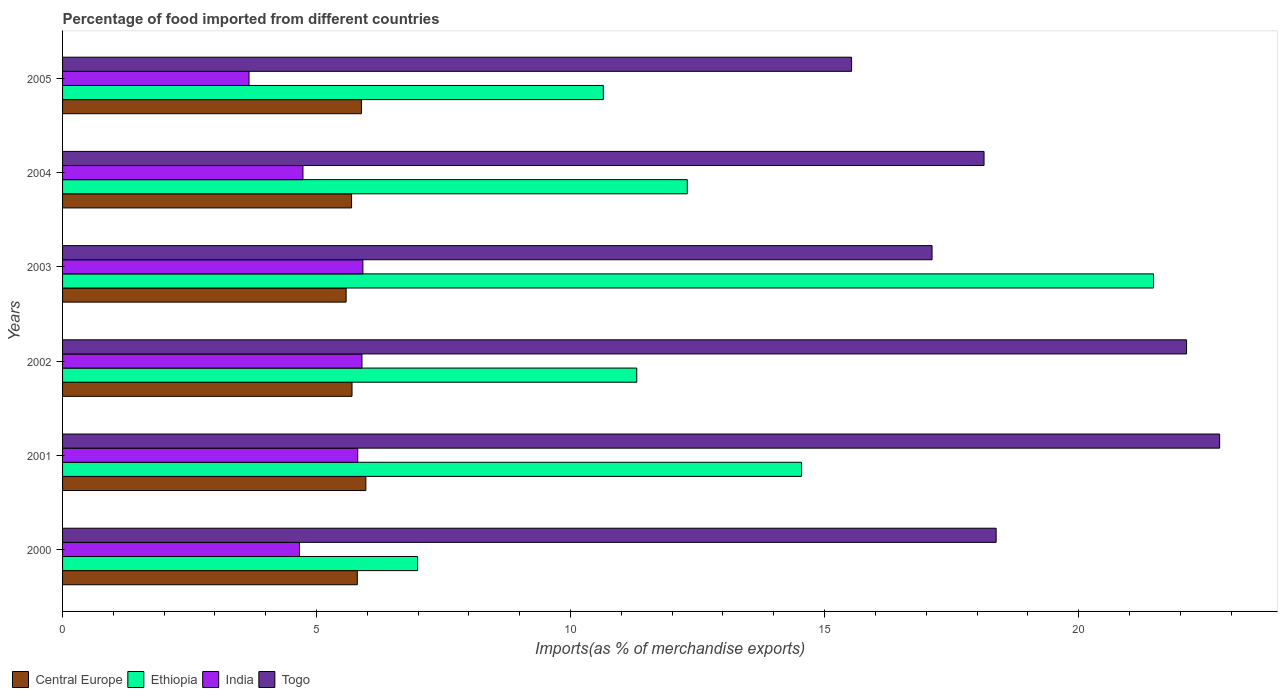How many groups of bars are there?
Offer a very short reply. 6. How many bars are there on the 4th tick from the top?
Make the answer very short. 4. How many bars are there on the 5th tick from the bottom?
Provide a succinct answer. 4. In how many cases, is the number of bars for a given year not equal to the number of legend labels?
Your answer should be very brief. 0. What is the percentage of imports to different countries in Togo in 2002?
Provide a short and direct response. 22.13. Across all years, what is the maximum percentage of imports to different countries in Togo?
Offer a very short reply. 22.78. Across all years, what is the minimum percentage of imports to different countries in Togo?
Make the answer very short. 15.53. What is the total percentage of imports to different countries in Central Europe in the graph?
Give a very brief answer. 34.62. What is the difference between the percentage of imports to different countries in Central Europe in 2002 and that in 2003?
Offer a very short reply. 0.12. What is the difference between the percentage of imports to different countries in Togo in 2000 and the percentage of imports to different countries in Central Europe in 2001?
Offer a very short reply. 12.41. What is the average percentage of imports to different countries in Ethiopia per year?
Make the answer very short. 12.88. In the year 2001, what is the difference between the percentage of imports to different countries in India and percentage of imports to different countries in Central Europe?
Give a very brief answer. -0.16. In how many years, is the percentage of imports to different countries in Central Europe greater than 8 %?
Offer a very short reply. 0. What is the ratio of the percentage of imports to different countries in Central Europe in 2000 to that in 2001?
Your response must be concise. 0.97. Is the percentage of imports to different countries in Ethiopia in 2000 less than that in 2003?
Keep it short and to the point. Yes. Is the difference between the percentage of imports to different countries in India in 2002 and 2003 greater than the difference between the percentage of imports to different countries in Central Europe in 2002 and 2003?
Make the answer very short. No. What is the difference between the highest and the second highest percentage of imports to different countries in Central Europe?
Make the answer very short. 0.09. What is the difference between the highest and the lowest percentage of imports to different countries in Togo?
Provide a short and direct response. 7.24. Is the sum of the percentage of imports to different countries in Central Europe in 2002 and 2003 greater than the maximum percentage of imports to different countries in Togo across all years?
Ensure brevity in your answer.  No. What does the 3rd bar from the top in 2001 represents?
Provide a short and direct response. Ethiopia. What does the 2nd bar from the bottom in 2003 represents?
Your answer should be compact. Ethiopia. Is it the case that in every year, the sum of the percentage of imports to different countries in India and percentage of imports to different countries in Togo is greater than the percentage of imports to different countries in Ethiopia?
Offer a very short reply. Yes. How many bars are there?
Provide a short and direct response. 24. Are all the bars in the graph horizontal?
Your response must be concise. Yes. How many years are there in the graph?
Provide a short and direct response. 6. What is the difference between two consecutive major ticks on the X-axis?
Your answer should be compact. 5. Does the graph contain any zero values?
Make the answer very short. No. Where does the legend appear in the graph?
Keep it short and to the point. Bottom left. How many legend labels are there?
Provide a succinct answer. 4. How are the legend labels stacked?
Make the answer very short. Horizontal. What is the title of the graph?
Make the answer very short. Percentage of food imported from different countries. What is the label or title of the X-axis?
Provide a succinct answer. Imports(as % of merchandise exports). What is the Imports(as % of merchandise exports) in Central Europe in 2000?
Give a very brief answer. 5.8. What is the Imports(as % of merchandise exports) in Ethiopia in 2000?
Provide a succinct answer. 6.99. What is the Imports(as % of merchandise exports) in India in 2000?
Your response must be concise. 4.66. What is the Imports(as % of merchandise exports) in Togo in 2000?
Your response must be concise. 18.38. What is the Imports(as % of merchandise exports) of Central Europe in 2001?
Ensure brevity in your answer.  5.97. What is the Imports(as % of merchandise exports) of Ethiopia in 2001?
Offer a very short reply. 14.55. What is the Imports(as % of merchandise exports) in India in 2001?
Provide a succinct answer. 5.81. What is the Imports(as % of merchandise exports) in Togo in 2001?
Offer a very short reply. 22.78. What is the Imports(as % of merchandise exports) in Central Europe in 2002?
Your response must be concise. 5.7. What is the Imports(as % of merchandise exports) of Ethiopia in 2002?
Provide a short and direct response. 11.3. What is the Imports(as % of merchandise exports) in India in 2002?
Keep it short and to the point. 5.89. What is the Imports(as % of merchandise exports) of Togo in 2002?
Provide a short and direct response. 22.13. What is the Imports(as % of merchandise exports) of Central Europe in 2003?
Give a very brief answer. 5.58. What is the Imports(as % of merchandise exports) in Ethiopia in 2003?
Your response must be concise. 21.47. What is the Imports(as % of merchandise exports) in India in 2003?
Ensure brevity in your answer.  5.91. What is the Imports(as % of merchandise exports) in Togo in 2003?
Offer a terse response. 17.12. What is the Imports(as % of merchandise exports) of Central Europe in 2004?
Your answer should be compact. 5.69. What is the Imports(as % of merchandise exports) in Ethiopia in 2004?
Your answer should be very brief. 12.3. What is the Imports(as % of merchandise exports) in India in 2004?
Offer a very short reply. 4.73. What is the Imports(as % of merchandise exports) in Togo in 2004?
Make the answer very short. 18.14. What is the Imports(as % of merchandise exports) of Central Europe in 2005?
Give a very brief answer. 5.88. What is the Imports(as % of merchandise exports) in Ethiopia in 2005?
Offer a very short reply. 10.64. What is the Imports(as % of merchandise exports) of India in 2005?
Your response must be concise. 3.67. What is the Imports(as % of merchandise exports) in Togo in 2005?
Your answer should be very brief. 15.53. Across all years, what is the maximum Imports(as % of merchandise exports) in Central Europe?
Your response must be concise. 5.97. Across all years, what is the maximum Imports(as % of merchandise exports) in Ethiopia?
Provide a short and direct response. 21.47. Across all years, what is the maximum Imports(as % of merchandise exports) of India?
Provide a short and direct response. 5.91. Across all years, what is the maximum Imports(as % of merchandise exports) of Togo?
Provide a short and direct response. 22.78. Across all years, what is the minimum Imports(as % of merchandise exports) of Central Europe?
Give a very brief answer. 5.58. Across all years, what is the minimum Imports(as % of merchandise exports) of Ethiopia?
Your answer should be very brief. 6.99. Across all years, what is the minimum Imports(as % of merchandise exports) of India?
Offer a very short reply. 3.67. Across all years, what is the minimum Imports(as % of merchandise exports) in Togo?
Give a very brief answer. 15.53. What is the total Imports(as % of merchandise exports) of Central Europe in the graph?
Give a very brief answer. 34.62. What is the total Imports(as % of merchandise exports) of Ethiopia in the graph?
Your response must be concise. 77.26. What is the total Imports(as % of merchandise exports) of India in the graph?
Your answer should be compact. 30.68. What is the total Imports(as % of merchandise exports) in Togo in the graph?
Make the answer very short. 114.06. What is the difference between the Imports(as % of merchandise exports) in Central Europe in 2000 and that in 2001?
Provide a succinct answer. -0.17. What is the difference between the Imports(as % of merchandise exports) in Ethiopia in 2000 and that in 2001?
Offer a very short reply. -7.56. What is the difference between the Imports(as % of merchandise exports) in India in 2000 and that in 2001?
Your answer should be compact. -1.15. What is the difference between the Imports(as % of merchandise exports) in Togo in 2000 and that in 2001?
Make the answer very short. -4.4. What is the difference between the Imports(as % of merchandise exports) of Central Europe in 2000 and that in 2002?
Your answer should be compact. 0.1. What is the difference between the Imports(as % of merchandise exports) in Ethiopia in 2000 and that in 2002?
Provide a short and direct response. -4.31. What is the difference between the Imports(as % of merchandise exports) in India in 2000 and that in 2002?
Your answer should be very brief. -1.23. What is the difference between the Imports(as % of merchandise exports) in Togo in 2000 and that in 2002?
Keep it short and to the point. -3.75. What is the difference between the Imports(as % of merchandise exports) in Central Europe in 2000 and that in 2003?
Provide a succinct answer. 0.22. What is the difference between the Imports(as % of merchandise exports) of Ethiopia in 2000 and that in 2003?
Provide a succinct answer. -14.49. What is the difference between the Imports(as % of merchandise exports) in India in 2000 and that in 2003?
Keep it short and to the point. -1.25. What is the difference between the Imports(as % of merchandise exports) of Togo in 2000 and that in 2003?
Keep it short and to the point. 1.26. What is the difference between the Imports(as % of merchandise exports) in Central Europe in 2000 and that in 2004?
Offer a terse response. 0.11. What is the difference between the Imports(as % of merchandise exports) in Ethiopia in 2000 and that in 2004?
Your answer should be compact. -5.31. What is the difference between the Imports(as % of merchandise exports) in India in 2000 and that in 2004?
Make the answer very short. -0.07. What is the difference between the Imports(as % of merchandise exports) in Togo in 2000 and that in 2004?
Your response must be concise. 0.24. What is the difference between the Imports(as % of merchandise exports) of Central Europe in 2000 and that in 2005?
Give a very brief answer. -0.08. What is the difference between the Imports(as % of merchandise exports) in Ethiopia in 2000 and that in 2005?
Ensure brevity in your answer.  -3.66. What is the difference between the Imports(as % of merchandise exports) of India in 2000 and that in 2005?
Give a very brief answer. 0.99. What is the difference between the Imports(as % of merchandise exports) in Togo in 2000 and that in 2005?
Provide a succinct answer. 2.85. What is the difference between the Imports(as % of merchandise exports) of Central Europe in 2001 and that in 2002?
Ensure brevity in your answer.  0.27. What is the difference between the Imports(as % of merchandise exports) of Ethiopia in 2001 and that in 2002?
Your response must be concise. 3.24. What is the difference between the Imports(as % of merchandise exports) of India in 2001 and that in 2002?
Offer a terse response. -0.08. What is the difference between the Imports(as % of merchandise exports) in Togo in 2001 and that in 2002?
Provide a succinct answer. 0.65. What is the difference between the Imports(as % of merchandise exports) in Central Europe in 2001 and that in 2003?
Offer a very short reply. 0.39. What is the difference between the Imports(as % of merchandise exports) of Ethiopia in 2001 and that in 2003?
Offer a very short reply. -6.93. What is the difference between the Imports(as % of merchandise exports) of India in 2001 and that in 2003?
Your response must be concise. -0.1. What is the difference between the Imports(as % of merchandise exports) of Togo in 2001 and that in 2003?
Provide a succinct answer. 5.66. What is the difference between the Imports(as % of merchandise exports) in Central Europe in 2001 and that in 2004?
Provide a short and direct response. 0.28. What is the difference between the Imports(as % of merchandise exports) in Ethiopia in 2001 and that in 2004?
Ensure brevity in your answer.  2.25. What is the difference between the Imports(as % of merchandise exports) of India in 2001 and that in 2004?
Offer a terse response. 1.08. What is the difference between the Imports(as % of merchandise exports) of Togo in 2001 and that in 2004?
Your answer should be compact. 4.64. What is the difference between the Imports(as % of merchandise exports) of Central Europe in 2001 and that in 2005?
Provide a short and direct response. 0.09. What is the difference between the Imports(as % of merchandise exports) in Ethiopia in 2001 and that in 2005?
Your response must be concise. 3.9. What is the difference between the Imports(as % of merchandise exports) in India in 2001 and that in 2005?
Offer a terse response. 2.14. What is the difference between the Imports(as % of merchandise exports) in Togo in 2001 and that in 2005?
Give a very brief answer. 7.24. What is the difference between the Imports(as % of merchandise exports) in Central Europe in 2002 and that in 2003?
Your response must be concise. 0.12. What is the difference between the Imports(as % of merchandise exports) of Ethiopia in 2002 and that in 2003?
Keep it short and to the point. -10.17. What is the difference between the Imports(as % of merchandise exports) in India in 2002 and that in 2003?
Offer a terse response. -0.02. What is the difference between the Imports(as % of merchandise exports) of Togo in 2002 and that in 2003?
Offer a very short reply. 5.01. What is the difference between the Imports(as % of merchandise exports) in Central Europe in 2002 and that in 2004?
Give a very brief answer. 0.01. What is the difference between the Imports(as % of merchandise exports) of Ethiopia in 2002 and that in 2004?
Offer a very short reply. -0.99. What is the difference between the Imports(as % of merchandise exports) of India in 2002 and that in 2004?
Ensure brevity in your answer.  1.16. What is the difference between the Imports(as % of merchandise exports) in Togo in 2002 and that in 2004?
Your response must be concise. 3.99. What is the difference between the Imports(as % of merchandise exports) in Central Europe in 2002 and that in 2005?
Offer a terse response. -0.19. What is the difference between the Imports(as % of merchandise exports) in Ethiopia in 2002 and that in 2005?
Your response must be concise. 0.66. What is the difference between the Imports(as % of merchandise exports) in India in 2002 and that in 2005?
Offer a very short reply. 2.22. What is the difference between the Imports(as % of merchandise exports) in Togo in 2002 and that in 2005?
Ensure brevity in your answer.  6.59. What is the difference between the Imports(as % of merchandise exports) in Central Europe in 2003 and that in 2004?
Ensure brevity in your answer.  -0.11. What is the difference between the Imports(as % of merchandise exports) of Ethiopia in 2003 and that in 2004?
Provide a short and direct response. 9.18. What is the difference between the Imports(as % of merchandise exports) in India in 2003 and that in 2004?
Your response must be concise. 1.18. What is the difference between the Imports(as % of merchandise exports) of Togo in 2003 and that in 2004?
Your answer should be very brief. -1.02. What is the difference between the Imports(as % of merchandise exports) in Central Europe in 2003 and that in 2005?
Your answer should be very brief. -0.3. What is the difference between the Imports(as % of merchandise exports) of Ethiopia in 2003 and that in 2005?
Make the answer very short. 10.83. What is the difference between the Imports(as % of merchandise exports) of India in 2003 and that in 2005?
Keep it short and to the point. 2.24. What is the difference between the Imports(as % of merchandise exports) of Togo in 2003 and that in 2005?
Make the answer very short. 1.58. What is the difference between the Imports(as % of merchandise exports) in Central Europe in 2004 and that in 2005?
Provide a succinct answer. -0.19. What is the difference between the Imports(as % of merchandise exports) in Ethiopia in 2004 and that in 2005?
Ensure brevity in your answer.  1.65. What is the difference between the Imports(as % of merchandise exports) in India in 2004 and that in 2005?
Offer a very short reply. 1.06. What is the difference between the Imports(as % of merchandise exports) of Togo in 2004 and that in 2005?
Give a very brief answer. 2.61. What is the difference between the Imports(as % of merchandise exports) in Central Europe in 2000 and the Imports(as % of merchandise exports) in Ethiopia in 2001?
Keep it short and to the point. -8.74. What is the difference between the Imports(as % of merchandise exports) of Central Europe in 2000 and the Imports(as % of merchandise exports) of India in 2001?
Keep it short and to the point. -0.01. What is the difference between the Imports(as % of merchandise exports) in Central Europe in 2000 and the Imports(as % of merchandise exports) in Togo in 2001?
Keep it short and to the point. -16.97. What is the difference between the Imports(as % of merchandise exports) in Ethiopia in 2000 and the Imports(as % of merchandise exports) in India in 2001?
Offer a terse response. 1.18. What is the difference between the Imports(as % of merchandise exports) of Ethiopia in 2000 and the Imports(as % of merchandise exports) of Togo in 2001?
Ensure brevity in your answer.  -15.79. What is the difference between the Imports(as % of merchandise exports) in India in 2000 and the Imports(as % of merchandise exports) in Togo in 2001?
Your answer should be very brief. -18.11. What is the difference between the Imports(as % of merchandise exports) of Central Europe in 2000 and the Imports(as % of merchandise exports) of Ethiopia in 2002?
Give a very brief answer. -5.5. What is the difference between the Imports(as % of merchandise exports) in Central Europe in 2000 and the Imports(as % of merchandise exports) in India in 2002?
Offer a very short reply. -0.09. What is the difference between the Imports(as % of merchandise exports) of Central Europe in 2000 and the Imports(as % of merchandise exports) of Togo in 2002?
Offer a very short reply. -16.32. What is the difference between the Imports(as % of merchandise exports) of Ethiopia in 2000 and the Imports(as % of merchandise exports) of India in 2002?
Your answer should be compact. 1.1. What is the difference between the Imports(as % of merchandise exports) of Ethiopia in 2000 and the Imports(as % of merchandise exports) of Togo in 2002?
Give a very brief answer. -15.14. What is the difference between the Imports(as % of merchandise exports) in India in 2000 and the Imports(as % of merchandise exports) in Togo in 2002?
Your answer should be very brief. -17.46. What is the difference between the Imports(as % of merchandise exports) in Central Europe in 2000 and the Imports(as % of merchandise exports) in Ethiopia in 2003?
Keep it short and to the point. -15.67. What is the difference between the Imports(as % of merchandise exports) in Central Europe in 2000 and the Imports(as % of merchandise exports) in India in 2003?
Your answer should be very brief. -0.11. What is the difference between the Imports(as % of merchandise exports) of Central Europe in 2000 and the Imports(as % of merchandise exports) of Togo in 2003?
Provide a short and direct response. -11.31. What is the difference between the Imports(as % of merchandise exports) in Ethiopia in 2000 and the Imports(as % of merchandise exports) in India in 2003?
Your response must be concise. 1.08. What is the difference between the Imports(as % of merchandise exports) in Ethiopia in 2000 and the Imports(as % of merchandise exports) in Togo in 2003?
Make the answer very short. -10.13. What is the difference between the Imports(as % of merchandise exports) in India in 2000 and the Imports(as % of merchandise exports) in Togo in 2003?
Your response must be concise. -12.45. What is the difference between the Imports(as % of merchandise exports) in Central Europe in 2000 and the Imports(as % of merchandise exports) in Ethiopia in 2004?
Give a very brief answer. -6.5. What is the difference between the Imports(as % of merchandise exports) in Central Europe in 2000 and the Imports(as % of merchandise exports) in India in 2004?
Your answer should be compact. 1.07. What is the difference between the Imports(as % of merchandise exports) of Central Europe in 2000 and the Imports(as % of merchandise exports) of Togo in 2004?
Give a very brief answer. -12.34. What is the difference between the Imports(as % of merchandise exports) in Ethiopia in 2000 and the Imports(as % of merchandise exports) in India in 2004?
Your response must be concise. 2.26. What is the difference between the Imports(as % of merchandise exports) of Ethiopia in 2000 and the Imports(as % of merchandise exports) of Togo in 2004?
Make the answer very short. -11.15. What is the difference between the Imports(as % of merchandise exports) in India in 2000 and the Imports(as % of merchandise exports) in Togo in 2004?
Provide a short and direct response. -13.48. What is the difference between the Imports(as % of merchandise exports) of Central Europe in 2000 and the Imports(as % of merchandise exports) of Ethiopia in 2005?
Your answer should be very brief. -4.84. What is the difference between the Imports(as % of merchandise exports) in Central Europe in 2000 and the Imports(as % of merchandise exports) in India in 2005?
Offer a very short reply. 2.13. What is the difference between the Imports(as % of merchandise exports) in Central Europe in 2000 and the Imports(as % of merchandise exports) in Togo in 2005?
Keep it short and to the point. -9.73. What is the difference between the Imports(as % of merchandise exports) of Ethiopia in 2000 and the Imports(as % of merchandise exports) of India in 2005?
Ensure brevity in your answer.  3.32. What is the difference between the Imports(as % of merchandise exports) in Ethiopia in 2000 and the Imports(as % of merchandise exports) in Togo in 2005?
Provide a succinct answer. -8.54. What is the difference between the Imports(as % of merchandise exports) of India in 2000 and the Imports(as % of merchandise exports) of Togo in 2005?
Make the answer very short. -10.87. What is the difference between the Imports(as % of merchandise exports) of Central Europe in 2001 and the Imports(as % of merchandise exports) of Ethiopia in 2002?
Offer a terse response. -5.33. What is the difference between the Imports(as % of merchandise exports) of Central Europe in 2001 and the Imports(as % of merchandise exports) of India in 2002?
Make the answer very short. 0.08. What is the difference between the Imports(as % of merchandise exports) of Central Europe in 2001 and the Imports(as % of merchandise exports) of Togo in 2002?
Ensure brevity in your answer.  -16.15. What is the difference between the Imports(as % of merchandise exports) in Ethiopia in 2001 and the Imports(as % of merchandise exports) in India in 2002?
Give a very brief answer. 8.65. What is the difference between the Imports(as % of merchandise exports) in Ethiopia in 2001 and the Imports(as % of merchandise exports) in Togo in 2002?
Offer a terse response. -7.58. What is the difference between the Imports(as % of merchandise exports) of India in 2001 and the Imports(as % of merchandise exports) of Togo in 2002?
Provide a succinct answer. -16.32. What is the difference between the Imports(as % of merchandise exports) of Central Europe in 2001 and the Imports(as % of merchandise exports) of Ethiopia in 2003?
Your response must be concise. -15.5. What is the difference between the Imports(as % of merchandise exports) in Central Europe in 2001 and the Imports(as % of merchandise exports) in India in 2003?
Ensure brevity in your answer.  0.06. What is the difference between the Imports(as % of merchandise exports) of Central Europe in 2001 and the Imports(as % of merchandise exports) of Togo in 2003?
Provide a short and direct response. -11.15. What is the difference between the Imports(as % of merchandise exports) in Ethiopia in 2001 and the Imports(as % of merchandise exports) in India in 2003?
Your answer should be very brief. 8.64. What is the difference between the Imports(as % of merchandise exports) of Ethiopia in 2001 and the Imports(as % of merchandise exports) of Togo in 2003?
Offer a terse response. -2.57. What is the difference between the Imports(as % of merchandise exports) of India in 2001 and the Imports(as % of merchandise exports) of Togo in 2003?
Ensure brevity in your answer.  -11.31. What is the difference between the Imports(as % of merchandise exports) in Central Europe in 2001 and the Imports(as % of merchandise exports) in Ethiopia in 2004?
Your response must be concise. -6.33. What is the difference between the Imports(as % of merchandise exports) in Central Europe in 2001 and the Imports(as % of merchandise exports) in India in 2004?
Your answer should be very brief. 1.24. What is the difference between the Imports(as % of merchandise exports) in Central Europe in 2001 and the Imports(as % of merchandise exports) in Togo in 2004?
Your answer should be compact. -12.17. What is the difference between the Imports(as % of merchandise exports) of Ethiopia in 2001 and the Imports(as % of merchandise exports) of India in 2004?
Your answer should be very brief. 9.81. What is the difference between the Imports(as % of merchandise exports) of Ethiopia in 2001 and the Imports(as % of merchandise exports) of Togo in 2004?
Provide a short and direct response. -3.59. What is the difference between the Imports(as % of merchandise exports) of India in 2001 and the Imports(as % of merchandise exports) of Togo in 2004?
Make the answer very short. -12.33. What is the difference between the Imports(as % of merchandise exports) in Central Europe in 2001 and the Imports(as % of merchandise exports) in Ethiopia in 2005?
Ensure brevity in your answer.  -4.67. What is the difference between the Imports(as % of merchandise exports) in Central Europe in 2001 and the Imports(as % of merchandise exports) in India in 2005?
Offer a terse response. 2.3. What is the difference between the Imports(as % of merchandise exports) of Central Europe in 2001 and the Imports(as % of merchandise exports) of Togo in 2005?
Your answer should be compact. -9.56. What is the difference between the Imports(as % of merchandise exports) of Ethiopia in 2001 and the Imports(as % of merchandise exports) of India in 2005?
Make the answer very short. 10.88. What is the difference between the Imports(as % of merchandise exports) in Ethiopia in 2001 and the Imports(as % of merchandise exports) in Togo in 2005?
Provide a succinct answer. -0.98. What is the difference between the Imports(as % of merchandise exports) of India in 2001 and the Imports(as % of merchandise exports) of Togo in 2005?
Your response must be concise. -9.72. What is the difference between the Imports(as % of merchandise exports) of Central Europe in 2002 and the Imports(as % of merchandise exports) of Ethiopia in 2003?
Keep it short and to the point. -15.78. What is the difference between the Imports(as % of merchandise exports) of Central Europe in 2002 and the Imports(as % of merchandise exports) of India in 2003?
Your response must be concise. -0.21. What is the difference between the Imports(as % of merchandise exports) in Central Europe in 2002 and the Imports(as % of merchandise exports) in Togo in 2003?
Give a very brief answer. -11.42. What is the difference between the Imports(as % of merchandise exports) in Ethiopia in 2002 and the Imports(as % of merchandise exports) in India in 2003?
Offer a terse response. 5.39. What is the difference between the Imports(as % of merchandise exports) in Ethiopia in 2002 and the Imports(as % of merchandise exports) in Togo in 2003?
Your response must be concise. -5.81. What is the difference between the Imports(as % of merchandise exports) of India in 2002 and the Imports(as % of merchandise exports) of Togo in 2003?
Offer a terse response. -11.22. What is the difference between the Imports(as % of merchandise exports) in Central Europe in 2002 and the Imports(as % of merchandise exports) in Ethiopia in 2004?
Make the answer very short. -6.6. What is the difference between the Imports(as % of merchandise exports) of Central Europe in 2002 and the Imports(as % of merchandise exports) of India in 2004?
Your answer should be very brief. 0.97. What is the difference between the Imports(as % of merchandise exports) of Central Europe in 2002 and the Imports(as % of merchandise exports) of Togo in 2004?
Your answer should be compact. -12.44. What is the difference between the Imports(as % of merchandise exports) in Ethiopia in 2002 and the Imports(as % of merchandise exports) in India in 2004?
Offer a terse response. 6.57. What is the difference between the Imports(as % of merchandise exports) in Ethiopia in 2002 and the Imports(as % of merchandise exports) in Togo in 2004?
Offer a very short reply. -6.84. What is the difference between the Imports(as % of merchandise exports) in India in 2002 and the Imports(as % of merchandise exports) in Togo in 2004?
Give a very brief answer. -12.25. What is the difference between the Imports(as % of merchandise exports) of Central Europe in 2002 and the Imports(as % of merchandise exports) of Ethiopia in 2005?
Keep it short and to the point. -4.95. What is the difference between the Imports(as % of merchandise exports) in Central Europe in 2002 and the Imports(as % of merchandise exports) in India in 2005?
Offer a terse response. 2.03. What is the difference between the Imports(as % of merchandise exports) in Central Europe in 2002 and the Imports(as % of merchandise exports) in Togo in 2005?
Provide a short and direct response. -9.83. What is the difference between the Imports(as % of merchandise exports) of Ethiopia in 2002 and the Imports(as % of merchandise exports) of India in 2005?
Make the answer very short. 7.63. What is the difference between the Imports(as % of merchandise exports) in Ethiopia in 2002 and the Imports(as % of merchandise exports) in Togo in 2005?
Offer a very short reply. -4.23. What is the difference between the Imports(as % of merchandise exports) in India in 2002 and the Imports(as % of merchandise exports) in Togo in 2005?
Offer a very short reply. -9.64. What is the difference between the Imports(as % of merchandise exports) of Central Europe in 2003 and the Imports(as % of merchandise exports) of Ethiopia in 2004?
Your answer should be compact. -6.72. What is the difference between the Imports(as % of merchandise exports) of Central Europe in 2003 and the Imports(as % of merchandise exports) of India in 2004?
Ensure brevity in your answer.  0.85. What is the difference between the Imports(as % of merchandise exports) in Central Europe in 2003 and the Imports(as % of merchandise exports) in Togo in 2004?
Ensure brevity in your answer.  -12.56. What is the difference between the Imports(as % of merchandise exports) in Ethiopia in 2003 and the Imports(as % of merchandise exports) in India in 2004?
Offer a terse response. 16.74. What is the difference between the Imports(as % of merchandise exports) in Ethiopia in 2003 and the Imports(as % of merchandise exports) in Togo in 2004?
Make the answer very short. 3.34. What is the difference between the Imports(as % of merchandise exports) of India in 2003 and the Imports(as % of merchandise exports) of Togo in 2004?
Offer a terse response. -12.23. What is the difference between the Imports(as % of merchandise exports) of Central Europe in 2003 and the Imports(as % of merchandise exports) of Ethiopia in 2005?
Make the answer very short. -5.06. What is the difference between the Imports(as % of merchandise exports) in Central Europe in 2003 and the Imports(as % of merchandise exports) in India in 2005?
Offer a terse response. 1.91. What is the difference between the Imports(as % of merchandise exports) in Central Europe in 2003 and the Imports(as % of merchandise exports) in Togo in 2005?
Your answer should be compact. -9.95. What is the difference between the Imports(as % of merchandise exports) in Ethiopia in 2003 and the Imports(as % of merchandise exports) in India in 2005?
Make the answer very short. 17.8. What is the difference between the Imports(as % of merchandise exports) of Ethiopia in 2003 and the Imports(as % of merchandise exports) of Togo in 2005?
Offer a terse response. 5.94. What is the difference between the Imports(as % of merchandise exports) of India in 2003 and the Imports(as % of merchandise exports) of Togo in 2005?
Your answer should be compact. -9.62. What is the difference between the Imports(as % of merchandise exports) of Central Europe in 2004 and the Imports(as % of merchandise exports) of Ethiopia in 2005?
Your answer should be compact. -4.96. What is the difference between the Imports(as % of merchandise exports) in Central Europe in 2004 and the Imports(as % of merchandise exports) in India in 2005?
Give a very brief answer. 2.02. What is the difference between the Imports(as % of merchandise exports) of Central Europe in 2004 and the Imports(as % of merchandise exports) of Togo in 2005?
Provide a short and direct response. -9.84. What is the difference between the Imports(as % of merchandise exports) in Ethiopia in 2004 and the Imports(as % of merchandise exports) in India in 2005?
Your answer should be very brief. 8.63. What is the difference between the Imports(as % of merchandise exports) of Ethiopia in 2004 and the Imports(as % of merchandise exports) of Togo in 2005?
Provide a succinct answer. -3.23. What is the difference between the Imports(as % of merchandise exports) of India in 2004 and the Imports(as % of merchandise exports) of Togo in 2005?
Provide a short and direct response. -10.8. What is the average Imports(as % of merchandise exports) in Central Europe per year?
Provide a succinct answer. 5.77. What is the average Imports(as % of merchandise exports) in Ethiopia per year?
Your answer should be compact. 12.88. What is the average Imports(as % of merchandise exports) in India per year?
Keep it short and to the point. 5.11. What is the average Imports(as % of merchandise exports) of Togo per year?
Your answer should be very brief. 19.01. In the year 2000, what is the difference between the Imports(as % of merchandise exports) of Central Europe and Imports(as % of merchandise exports) of Ethiopia?
Give a very brief answer. -1.19. In the year 2000, what is the difference between the Imports(as % of merchandise exports) of Central Europe and Imports(as % of merchandise exports) of India?
Offer a very short reply. 1.14. In the year 2000, what is the difference between the Imports(as % of merchandise exports) of Central Europe and Imports(as % of merchandise exports) of Togo?
Give a very brief answer. -12.58. In the year 2000, what is the difference between the Imports(as % of merchandise exports) of Ethiopia and Imports(as % of merchandise exports) of India?
Your response must be concise. 2.33. In the year 2000, what is the difference between the Imports(as % of merchandise exports) of Ethiopia and Imports(as % of merchandise exports) of Togo?
Offer a terse response. -11.39. In the year 2000, what is the difference between the Imports(as % of merchandise exports) of India and Imports(as % of merchandise exports) of Togo?
Your answer should be compact. -13.71. In the year 2001, what is the difference between the Imports(as % of merchandise exports) in Central Europe and Imports(as % of merchandise exports) in Ethiopia?
Ensure brevity in your answer.  -8.58. In the year 2001, what is the difference between the Imports(as % of merchandise exports) in Central Europe and Imports(as % of merchandise exports) in India?
Your answer should be very brief. 0.16. In the year 2001, what is the difference between the Imports(as % of merchandise exports) in Central Europe and Imports(as % of merchandise exports) in Togo?
Offer a terse response. -16.81. In the year 2001, what is the difference between the Imports(as % of merchandise exports) in Ethiopia and Imports(as % of merchandise exports) in India?
Provide a short and direct response. 8.74. In the year 2001, what is the difference between the Imports(as % of merchandise exports) of Ethiopia and Imports(as % of merchandise exports) of Togo?
Your response must be concise. -8.23. In the year 2001, what is the difference between the Imports(as % of merchandise exports) in India and Imports(as % of merchandise exports) in Togo?
Offer a very short reply. -16.97. In the year 2002, what is the difference between the Imports(as % of merchandise exports) in Central Europe and Imports(as % of merchandise exports) in Ethiopia?
Your response must be concise. -5.61. In the year 2002, what is the difference between the Imports(as % of merchandise exports) of Central Europe and Imports(as % of merchandise exports) of India?
Provide a short and direct response. -0.2. In the year 2002, what is the difference between the Imports(as % of merchandise exports) of Central Europe and Imports(as % of merchandise exports) of Togo?
Offer a terse response. -16.43. In the year 2002, what is the difference between the Imports(as % of merchandise exports) in Ethiopia and Imports(as % of merchandise exports) in India?
Give a very brief answer. 5.41. In the year 2002, what is the difference between the Imports(as % of merchandise exports) in Ethiopia and Imports(as % of merchandise exports) in Togo?
Offer a terse response. -10.82. In the year 2002, what is the difference between the Imports(as % of merchandise exports) of India and Imports(as % of merchandise exports) of Togo?
Your response must be concise. -16.23. In the year 2003, what is the difference between the Imports(as % of merchandise exports) in Central Europe and Imports(as % of merchandise exports) in Ethiopia?
Ensure brevity in your answer.  -15.89. In the year 2003, what is the difference between the Imports(as % of merchandise exports) in Central Europe and Imports(as % of merchandise exports) in India?
Provide a succinct answer. -0.33. In the year 2003, what is the difference between the Imports(as % of merchandise exports) of Central Europe and Imports(as % of merchandise exports) of Togo?
Give a very brief answer. -11.53. In the year 2003, what is the difference between the Imports(as % of merchandise exports) of Ethiopia and Imports(as % of merchandise exports) of India?
Give a very brief answer. 15.56. In the year 2003, what is the difference between the Imports(as % of merchandise exports) in Ethiopia and Imports(as % of merchandise exports) in Togo?
Your answer should be compact. 4.36. In the year 2003, what is the difference between the Imports(as % of merchandise exports) in India and Imports(as % of merchandise exports) in Togo?
Your answer should be very brief. -11.2. In the year 2004, what is the difference between the Imports(as % of merchandise exports) in Central Europe and Imports(as % of merchandise exports) in Ethiopia?
Give a very brief answer. -6.61. In the year 2004, what is the difference between the Imports(as % of merchandise exports) of Central Europe and Imports(as % of merchandise exports) of India?
Ensure brevity in your answer.  0.96. In the year 2004, what is the difference between the Imports(as % of merchandise exports) in Central Europe and Imports(as % of merchandise exports) in Togo?
Offer a very short reply. -12.45. In the year 2004, what is the difference between the Imports(as % of merchandise exports) in Ethiopia and Imports(as % of merchandise exports) in India?
Provide a succinct answer. 7.57. In the year 2004, what is the difference between the Imports(as % of merchandise exports) in Ethiopia and Imports(as % of merchandise exports) in Togo?
Provide a succinct answer. -5.84. In the year 2004, what is the difference between the Imports(as % of merchandise exports) in India and Imports(as % of merchandise exports) in Togo?
Make the answer very short. -13.41. In the year 2005, what is the difference between the Imports(as % of merchandise exports) in Central Europe and Imports(as % of merchandise exports) in Ethiopia?
Offer a terse response. -4.76. In the year 2005, what is the difference between the Imports(as % of merchandise exports) in Central Europe and Imports(as % of merchandise exports) in India?
Keep it short and to the point. 2.21. In the year 2005, what is the difference between the Imports(as % of merchandise exports) in Central Europe and Imports(as % of merchandise exports) in Togo?
Provide a succinct answer. -9.65. In the year 2005, what is the difference between the Imports(as % of merchandise exports) in Ethiopia and Imports(as % of merchandise exports) in India?
Offer a very short reply. 6.97. In the year 2005, what is the difference between the Imports(as % of merchandise exports) of Ethiopia and Imports(as % of merchandise exports) of Togo?
Offer a terse response. -4.89. In the year 2005, what is the difference between the Imports(as % of merchandise exports) of India and Imports(as % of merchandise exports) of Togo?
Offer a terse response. -11.86. What is the ratio of the Imports(as % of merchandise exports) of Central Europe in 2000 to that in 2001?
Your answer should be compact. 0.97. What is the ratio of the Imports(as % of merchandise exports) of Ethiopia in 2000 to that in 2001?
Give a very brief answer. 0.48. What is the ratio of the Imports(as % of merchandise exports) in India in 2000 to that in 2001?
Your response must be concise. 0.8. What is the ratio of the Imports(as % of merchandise exports) of Togo in 2000 to that in 2001?
Give a very brief answer. 0.81. What is the ratio of the Imports(as % of merchandise exports) in Central Europe in 2000 to that in 2002?
Give a very brief answer. 1.02. What is the ratio of the Imports(as % of merchandise exports) of Ethiopia in 2000 to that in 2002?
Keep it short and to the point. 0.62. What is the ratio of the Imports(as % of merchandise exports) of India in 2000 to that in 2002?
Your answer should be compact. 0.79. What is the ratio of the Imports(as % of merchandise exports) in Togo in 2000 to that in 2002?
Your response must be concise. 0.83. What is the ratio of the Imports(as % of merchandise exports) of Central Europe in 2000 to that in 2003?
Make the answer very short. 1.04. What is the ratio of the Imports(as % of merchandise exports) of Ethiopia in 2000 to that in 2003?
Provide a short and direct response. 0.33. What is the ratio of the Imports(as % of merchandise exports) in India in 2000 to that in 2003?
Your answer should be very brief. 0.79. What is the ratio of the Imports(as % of merchandise exports) of Togo in 2000 to that in 2003?
Offer a very short reply. 1.07. What is the ratio of the Imports(as % of merchandise exports) of Central Europe in 2000 to that in 2004?
Your answer should be compact. 1.02. What is the ratio of the Imports(as % of merchandise exports) of Ethiopia in 2000 to that in 2004?
Offer a terse response. 0.57. What is the ratio of the Imports(as % of merchandise exports) in India in 2000 to that in 2004?
Provide a short and direct response. 0.99. What is the ratio of the Imports(as % of merchandise exports) of Togo in 2000 to that in 2004?
Your answer should be very brief. 1.01. What is the ratio of the Imports(as % of merchandise exports) of Central Europe in 2000 to that in 2005?
Make the answer very short. 0.99. What is the ratio of the Imports(as % of merchandise exports) in Ethiopia in 2000 to that in 2005?
Your answer should be compact. 0.66. What is the ratio of the Imports(as % of merchandise exports) of India in 2000 to that in 2005?
Keep it short and to the point. 1.27. What is the ratio of the Imports(as % of merchandise exports) of Togo in 2000 to that in 2005?
Ensure brevity in your answer.  1.18. What is the ratio of the Imports(as % of merchandise exports) in Central Europe in 2001 to that in 2002?
Make the answer very short. 1.05. What is the ratio of the Imports(as % of merchandise exports) of Ethiopia in 2001 to that in 2002?
Your answer should be very brief. 1.29. What is the ratio of the Imports(as % of merchandise exports) in India in 2001 to that in 2002?
Your response must be concise. 0.99. What is the ratio of the Imports(as % of merchandise exports) in Togo in 2001 to that in 2002?
Your answer should be very brief. 1.03. What is the ratio of the Imports(as % of merchandise exports) in Central Europe in 2001 to that in 2003?
Your answer should be compact. 1.07. What is the ratio of the Imports(as % of merchandise exports) of Ethiopia in 2001 to that in 2003?
Keep it short and to the point. 0.68. What is the ratio of the Imports(as % of merchandise exports) in India in 2001 to that in 2003?
Your answer should be compact. 0.98. What is the ratio of the Imports(as % of merchandise exports) in Togo in 2001 to that in 2003?
Provide a short and direct response. 1.33. What is the ratio of the Imports(as % of merchandise exports) of Central Europe in 2001 to that in 2004?
Ensure brevity in your answer.  1.05. What is the ratio of the Imports(as % of merchandise exports) of Ethiopia in 2001 to that in 2004?
Provide a short and direct response. 1.18. What is the ratio of the Imports(as % of merchandise exports) in India in 2001 to that in 2004?
Offer a terse response. 1.23. What is the ratio of the Imports(as % of merchandise exports) in Togo in 2001 to that in 2004?
Provide a short and direct response. 1.26. What is the ratio of the Imports(as % of merchandise exports) in Central Europe in 2001 to that in 2005?
Your answer should be compact. 1.01. What is the ratio of the Imports(as % of merchandise exports) in Ethiopia in 2001 to that in 2005?
Offer a very short reply. 1.37. What is the ratio of the Imports(as % of merchandise exports) of India in 2001 to that in 2005?
Your answer should be compact. 1.58. What is the ratio of the Imports(as % of merchandise exports) in Togo in 2001 to that in 2005?
Make the answer very short. 1.47. What is the ratio of the Imports(as % of merchandise exports) in Central Europe in 2002 to that in 2003?
Provide a short and direct response. 1.02. What is the ratio of the Imports(as % of merchandise exports) of Ethiopia in 2002 to that in 2003?
Provide a short and direct response. 0.53. What is the ratio of the Imports(as % of merchandise exports) of Togo in 2002 to that in 2003?
Your response must be concise. 1.29. What is the ratio of the Imports(as % of merchandise exports) in Ethiopia in 2002 to that in 2004?
Give a very brief answer. 0.92. What is the ratio of the Imports(as % of merchandise exports) of India in 2002 to that in 2004?
Give a very brief answer. 1.25. What is the ratio of the Imports(as % of merchandise exports) of Togo in 2002 to that in 2004?
Make the answer very short. 1.22. What is the ratio of the Imports(as % of merchandise exports) of Central Europe in 2002 to that in 2005?
Offer a very short reply. 0.97. What is the ratio of the Imports(as % of merchandise exports) in Ethiopia in 2002 to that in 2005?
Provide a short and direct response. 1.06. What is the ratio of the Imports(as % of merchandise exports) of India in 2002 to that in 2005?
Offer a very short reply. 1.61. What is the ratio of the Imports(as % of merchandise exports) of Togo in 2002 to that in 2005?
Ensure brevity in your answer.  1.42. What is the ratio of the Imports(as % of merchandise exports) of Central Europe in 2003 to that in 2004?
Provide a short and direct response. 0.98. What is the ratio of the Imports(as % of merchandise exports) in Ethiopia in 2003 to that in 2004?
Give a very brief answer. 1.75. What is the ratio of the Imports(as % of merchandise exports) of India in 2003 to that in 2004?
Provide a succinct answer. 1.25. What is the ratio of the Imports(as % of merchandise exports) in Togo in 2003 to that in 2004?
Offer a very short reply. 0.94. What is the ratio of the Imports(as % of merchandise exports) in Central Europe in 2003 to that in 2005?
Offer a terse response. 0.95. What is the ratio of the Imports(as % of merchandise exports) of Ethiopia in 2003 to that in 2005?
Offer a terse response. 2.02. What is the ratio of the Imports(as % of merchandise exports) of India in 2003 to that in 2005?
Ensure brevity in your answer.  1.61. What is the ratio of the Imports(as % of merchandise exports) in Togo in 2003 to that in 2005?
Provide a short and direct response. 1.1. What is the ratio of the Imports(as % of merchandise exports) in Central Europe in 2004 to that in 2005?
Your answer should be compact. 0.97. What is the ratio of the Imports(as % of merchandise exports) of Ethiopia in 2004 to that in 2005?
Make the answer very short. 1.16. What is the ratio of the Imports(as % of merchandise exports) of India in 2004 to that in 2005?
Your answer should be very brief. 1.29. What is the ratio of the Imports(as % of merchandise exports) of Togo in 2004 to that in 2005?
Keep it short and to the point. 1.17. What is the difference between the highest and the second highest Imports(as % of merchandise exports) of Central Europe?
Make the answer very short. 0.09. What is the difference between the highest and the second highest Imports(as % of merchandise exports) of Ethiopia?
Your response must be concise. 6.93. What is the difference between the highest and the second highest Imports(as % of merchandise exports) in India?
Make the answer very short. 0.02. What is the difference between the highest and the second highest Imports(as % of merchandise exports) of Togo?
Your answer should be very brief. 0.65. What is the difference between the highest and the lowest Imports(as % of merchandise exports) of Central Europe?
Keep it short and to the point. 0.39. What is the difference between the highest and the lowest Imports(as % of merchandise exports) of Ethiopia?
Give a very brief answer. 14.49. What is the difference between the highest and the lowest Imports(as % of merchandise exports) of India?
Your response must be concise. 2.24. What is the difference between the highest and the lowest Imports(as % of merchandise exports) in Togo?
Make the answer very short. 7.24. 